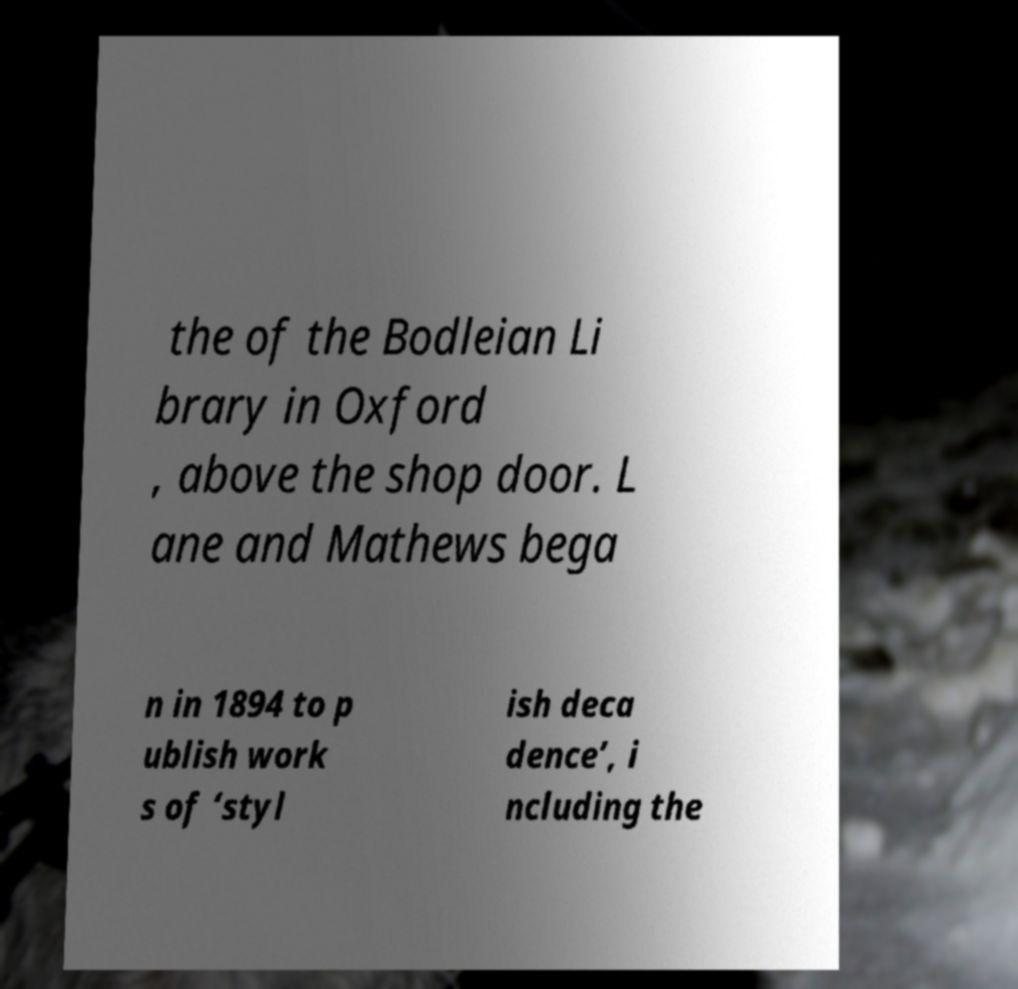What messages or text are displayed in this image? I need them in a readable, typed format. the of the Bodleian Li brary in Oxford , above the shop door. L ane and Mathews bega n in 1894 to p ublish work s of ‘styl ish deca dence’, i ncluding the 